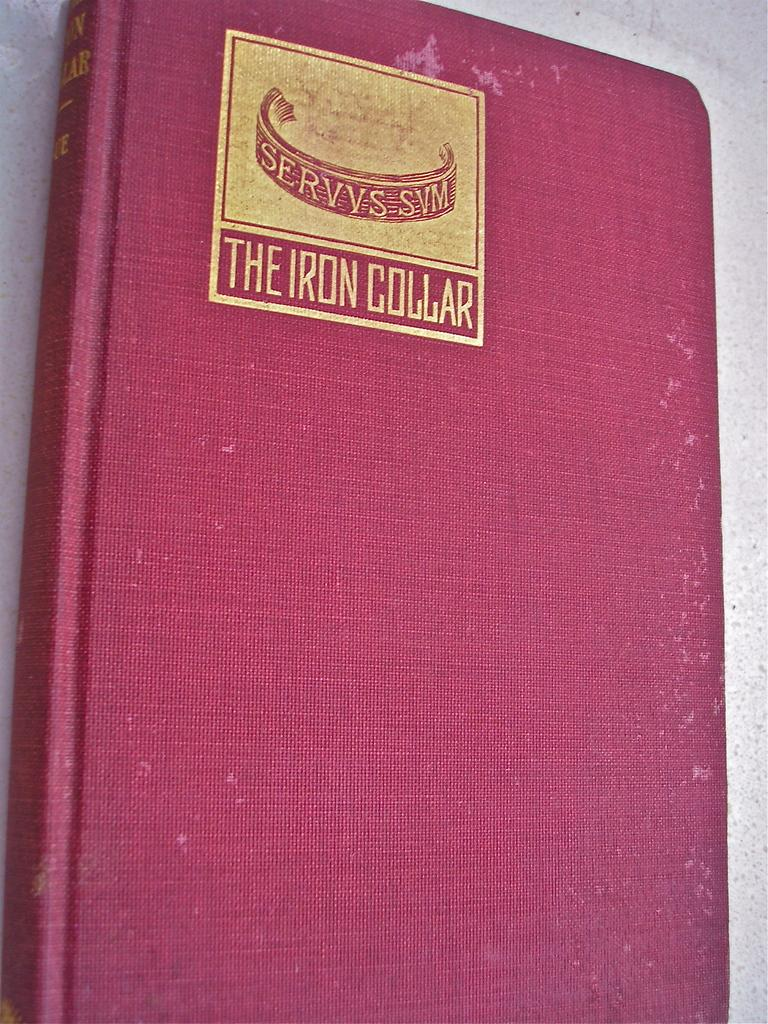<image>
Render a clear and concise summary of the photo. A red notebook has an emblem that says THE IRON COLLAR on it. 